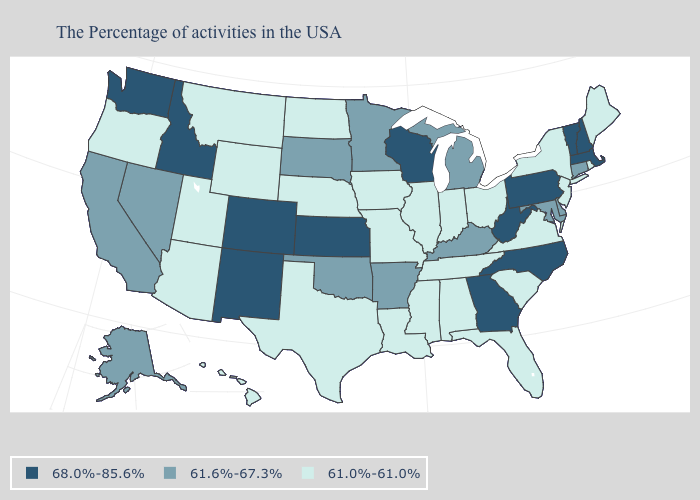Name the states that have a value in the range 61.6%-67.3%?
Write a very short answer. Connecticut, Delaware, Maryland, Michigan, Kentucky, Arkansas, Minnesota, Oklahoma, South Dakota, Nevada, California, Alaska. Name the states that have a value in the range 61.0%-61.0%?
Concise answer only. Maine, Rhode Island, New York, New Jersey, Virginia, South Carolina, Ohio, Florida, Indiana, Alabama, Tennessee, Illinois, Mississippi, Louisiana, Missouri, Iowa, Nebraska, Texas, North Dakota, Wyoming, Utah, Montana, Arizona, Oregon, Hawaii. Name the states that have a value in the range 61.0%-61.0%?
Quick response, please. Maine, Rhode Island, New York, New Jersey, Virginia, South Carolina, Ohio, Florida, Indiana, Alabama, Tennessee, Illinois, Mississippi, Louisiana, Missouri, Iowa, Nebraska, Texas, North Dakota, Wyoming, Utah, Montana, Arizona, Oregon, Hawaii. What is the value of Utah?
Quick response, please. 61.0%-61.0%. Does the first symbol in the legend represent the smallest category?
Keep it brief. No. What is the highest value in the USA?
Quick response, please. 68.0%-85.6%. What is the value of New Jersey?
Quick response, please. 61.0%-61.0%. Among the states that border Montana , does Idaho have the highest value?
Quick response, please. Yes. What is the highest value in the MidWest ?
Short answer required. 68.0%-85.6%. Name the states that have a value in the range 61.6%-67.3%?
Quick response, please. Connecticut, Delaware, Maryland, Michigan, Kentucky, Arkansas, Minnesota, Oklahoma, South Dakota, Nevada, California, Alaska. What is the value of Florida?
Concise answer only. 61.0%-61.0%. Name the states that have a value in the range 68.0%-85.6%?
Answer briefly. Massachusetts, New Hampshire, Vermont, Pennsylvania, North Carolina, West Virginia, Georgia, Wisconsin, Kansas, Colorado, New Mexico, Idaho, Washington. Which states have the lowest value in the USA?
Quick response, please. Maine, Rhode Island, New York, New Jersey, Virginia, South Carolina, Ohio, Florida, Indiana, Alabama, Tennessee, Illinois, Mississippi, Louisiana, Missouri, Iowa, Nebraska, Texas, North Dakota, Wyoming, Utah, Montana, Arizona, Oregon, Hawaii. Name the states that have a value in the range 68.0%-85.6%?
Quick response, please. Massachusetts, New Hampshire, Vermont, Pennsylvania, North Carolina, West Virginia, Georgia, Wisconsin, Kansas, Colorado, New Mexico, Idaho, Washington. Name the states that have a value in the range 68.0%-85.6%?
Concise answer only. Massachusetts, New Hampshire, Vermont, Pennsylvania, North Carolina, West Virginia, Georgia, Wisconsin, Kansas, Colorado, New Mexico, Idaho, Washington. 